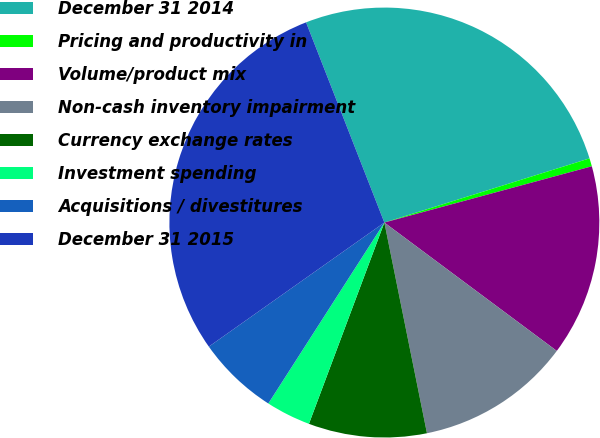Convert chart to OTSL. <chart><loc_0><loc_0><loc_500><loc_500><pie_chart><fcel>December 31 2014<fcel>Pricing and productivity in<fcel>Volume/product mix<fcel>Non-cash inventory impairment<fcel>Currency exchange rates<fcel>Investment spending<fcel>Acquisitions / divestitures<fcel>December 31 2015<nl><fcel>26.11%<fcel>0.61%<fcel>14.4%<fcel>11.64%<fcel>8.88%<fcel>3.37%<fcel>6.13%<fcel>28.86%<nl></chart> 